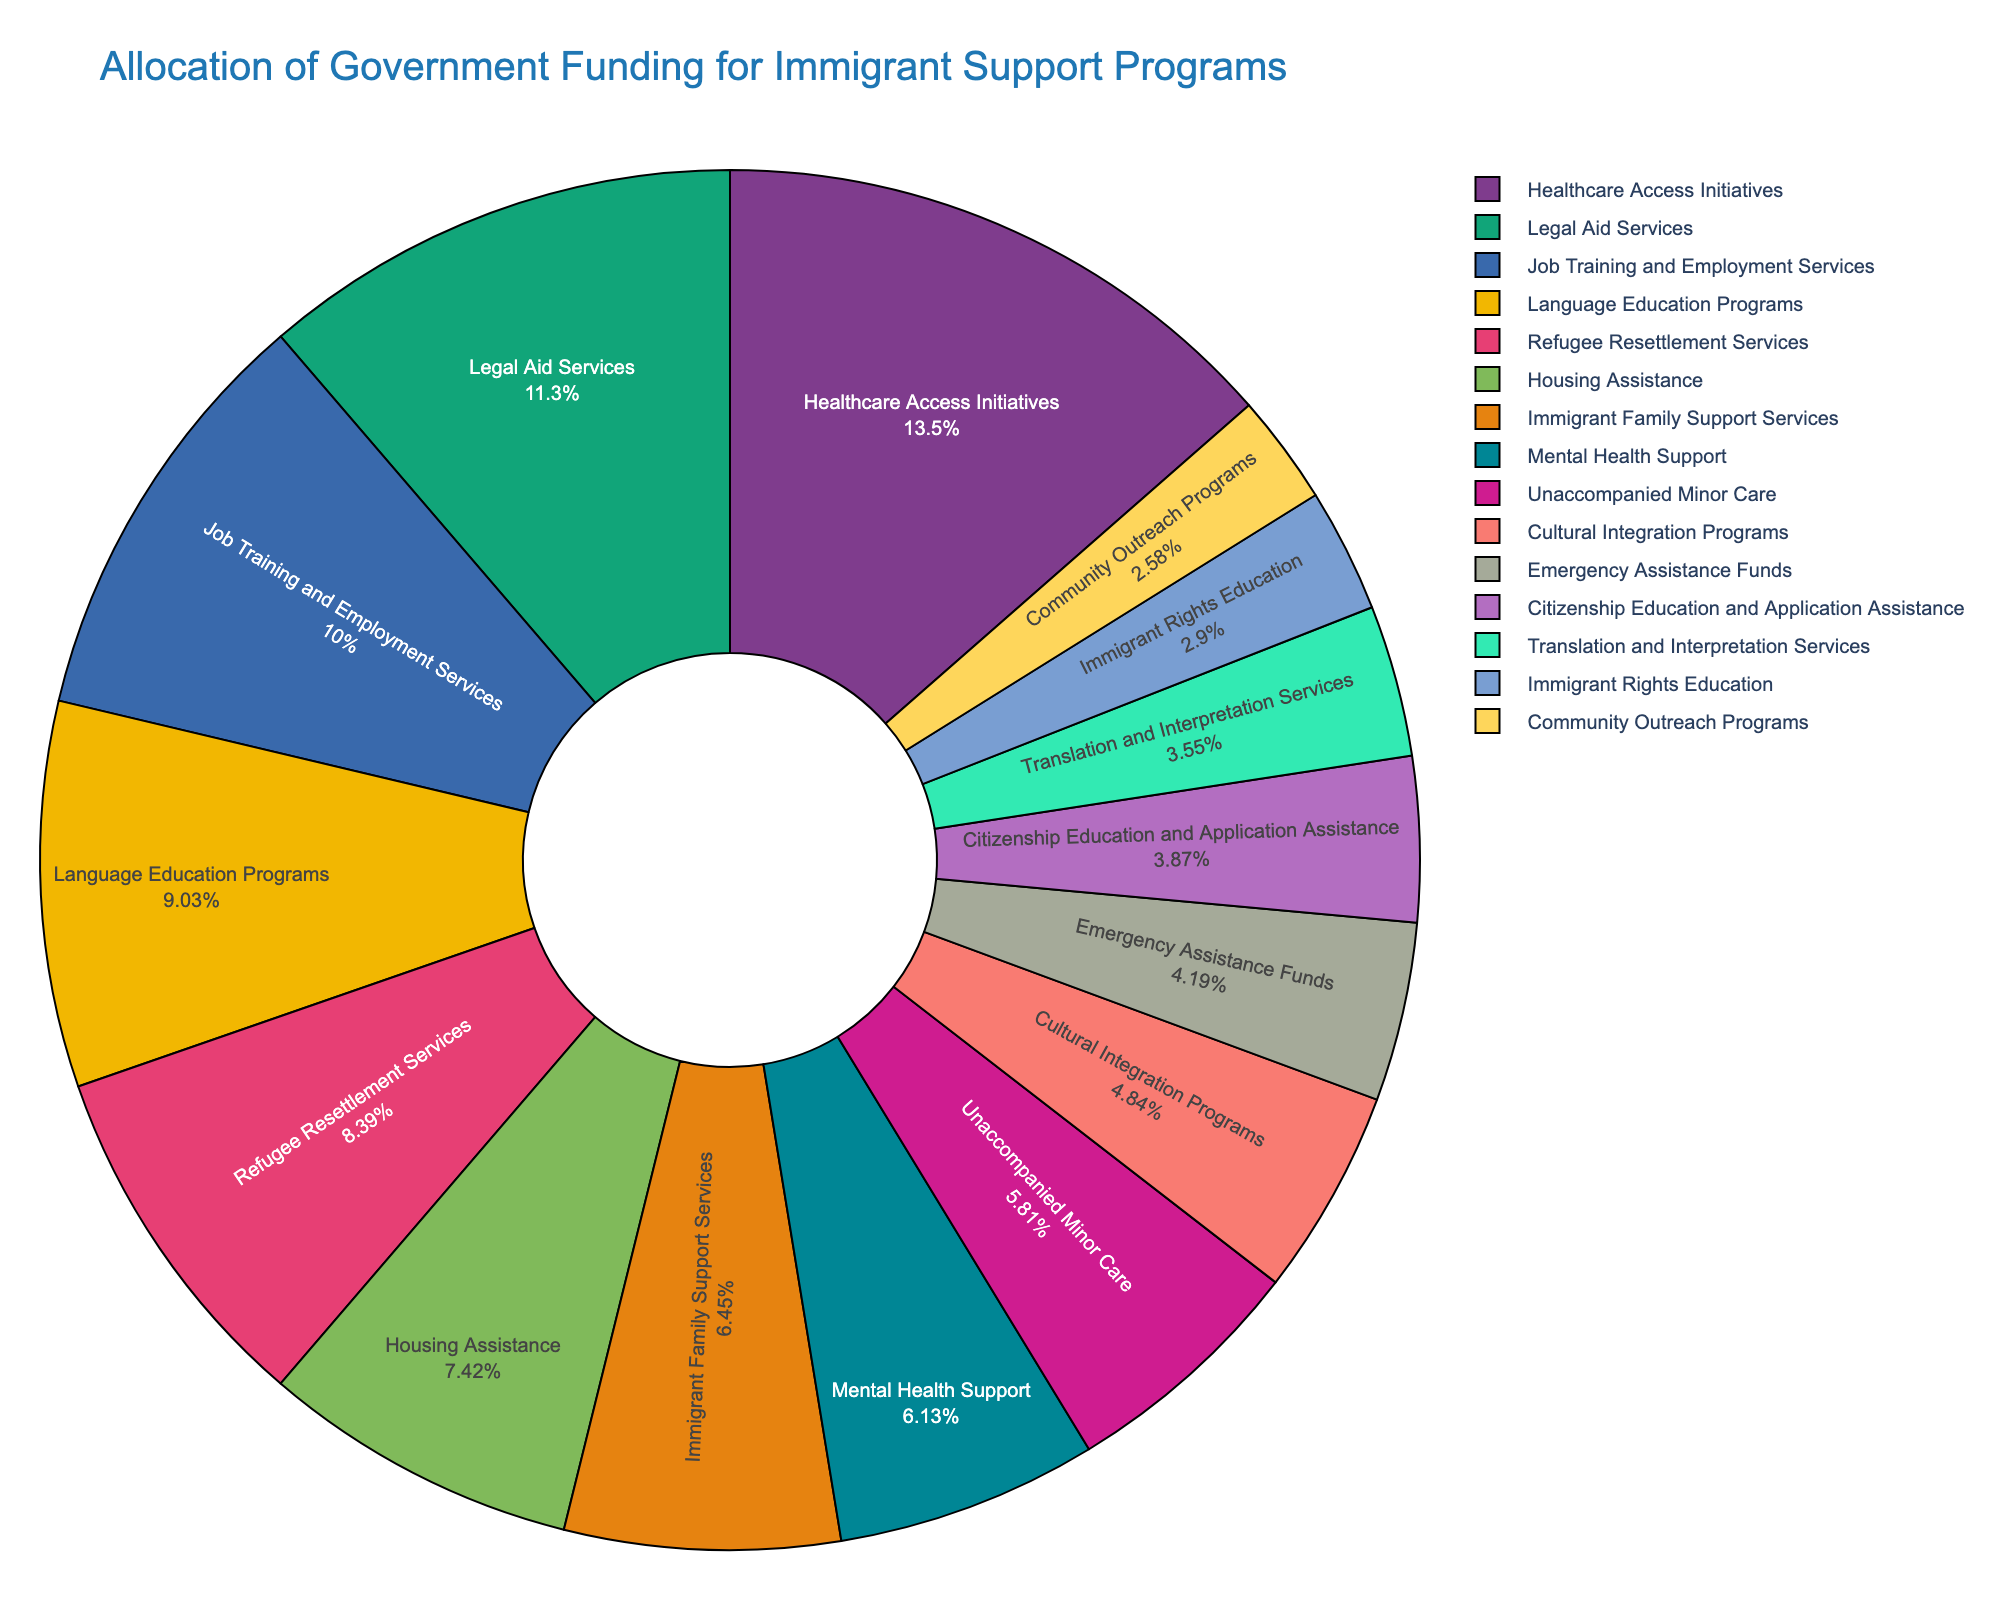How much funding is allocated to Healthcare Access Initiatives and Job Training and Employment Services combined? Combine the allocations for Healthcare Access Initiatives ($420 million) and Job Training and Employment Services ($310 million). The total is $420 million + $310 million = $730 million.
Answer: 730 million Which category has the lowest funding allocation, and what is the amount? The category with the lowest funding allocation is Community Outreach Programs, which is $80 million.
Answer: Community Outreach Programs, 80 million How does the funding for Legal Aid Services compare to that for Language Education Programs? Legal Aid Services has $350 million allocated, which is $70 million more than the $280 million allocated for Language Education Programs.
Answer: Legal Aid Services has 70 million more What is the percentage of the total funding allocated to Mental Health Support? Calculate the percentage by dividing the funding for Mental Health Support ($190 million) by the total funding for all categories, then multiply by 100. Total funding = $350 + $280 + $420 + $310 + $230 + $190 + $150 + $260 + $120 + $200 + $180 + $90 + $110 + $80 + $130 = $3100 million. The percentage is ($190 / $3100) * 100 ≈ 6.1%.
Answer: 6.1% Is the funding for Refugee Resettlement Services greater than the combined funding for Cultural Integration Programs and Citizenship Education and Application Assistance? Refugee Resettlement Services has $260 million allocated. The combined funding for Cultural Integration Programs ($150 million) and Citizenship Education and Application Assistance ($120 million) is $150 million + $120 million = $270 million, which is more than $260 million.
Answer: No Which category has the second-highest funding allocation and what is the amount? The second-highest funding allocation is Healthcare Access Initiatives with $420 million, after Housing Assistance.
Answer: Healthcare Access Initiatives, 420 million What is the difference in funding between Housing Assistance and Emergency Assistance Funds? Housing Assistance has $230 million and Emergency Assistance Funds have $130 million. The difference is $230 million - $130 million = $100 million.
Answer: 100 million What are the top three categories in terms of funding allocation? The top three categories in terms of funding are Healthcare Access Initiatives ($420 million), Legal Aid Services ($350 million), and Job Training and Employment Services ($310 million).
Answer: Healthcare Access Initiatives, Legal Aid Services, Job Training and Employment Services How much more funding does Healthcare Access Initiatives receive than Language Education Programs? Healthcare Access Initiatives receives $420 million, while Language Education Programs receive $280 million. The difference is $420 million - $280 million = $140 million.
Answer: 140 million 